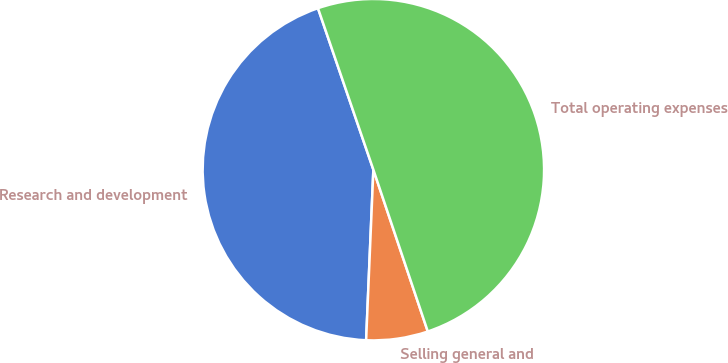<chart> <loc_0><loc_0><loc_500><loc_500><pie_chart><fcel>Research and development<fcel>Selling general and<fcel>Total operating expenses<nl><fcel>44.06%<fcel>5.84%<fcel>50.09%<nl></chart> 